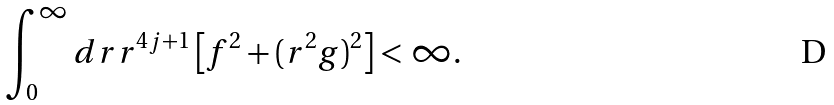Convert formula to latex. <formula><loc_0><loc_0><loc_500><loc_500>\int _ { 0 } ^ { \infty } d r r ^ { 4 j + 1 } \left [ f ^ { 2 } + ( r ^ { 2 } g ) ^ { 2 } \right ] < \infty .</formula> 